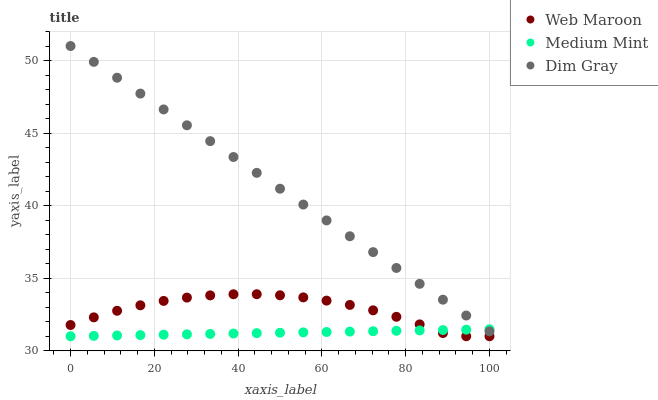Does Medium Mint have the minimum area under the curve?
Answer yes or no. Yes. Does Dim Gray have the maximum area under the curve?
Answer yes or no. Yes. Does Web Maroon have the minimum area under the curve?
Answer yes or no. No. Does Web Maroon have the maximum area under the curve?
Answer yes or no. No. Is Medium Mint the smoothest?
Answer yes or no. Yes. Is Web Maroon the roughest?
Answer yes or no. Yes. Is Dim Gray the smoothest?
Answer yes or no. No. Is Dim Gray the roughest?
Answer yes or no. No. Does Medium Mint have the lowest value?
Answer yes or no. Yes. Does Dim Gray have the lowest value?
Answer yes or no. No. Does Dim Gray have the highest value?
Answer yes or no. Yes. Does Web Maroon have the highest value?
Answer yes or no. No. Is Web Maroon less than Dim Gray?
Answer yes or no. Yes. Is Dim Gray greater than Web Maroon?
Answer yes or no. Yes. Does Web Maroon intersect Medium Mint?
Answer yes or no. Yes. Is Web Maroon less than Medium Mint?
Answer yes or no. No. Is Web Maroon greater than Medium Mint?
Answer yes or no. No. Does Web Maroon intersect Dim Gray?
Answer yes or no. No. 